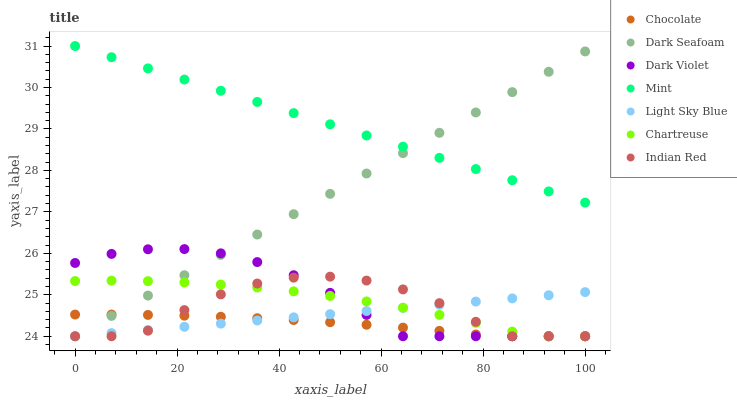Does Chocolate have the minimum area under the curve?
Answer yes or no. Yes. Does Mint have the maximum area under the curve?
Answer yes or no. Yes. Does Dark Violet have the minimum area under the curve?
Answer yes or no. No. Does Dark Violet have the maximum area under the curve?
Answer yes or no. No. Is Light Sky Blue the smoothest?
Answer yes or no. Yes. Is Indian Red the roughest?
Answer yes or no. Yes. Is Dark Violet the smoothest?
Answer yes or no. No. Is Dark Violet the roughest?
Answer yes or no. No. Does Chartreuse have the lowest value?
Answer yes or no. Yes. Does Mint have the lowest value?
Answer yes or no. No. Does Mint have the highest value?
Answer yes or no. Yes. Does Dark Violet have the highest value?
Answer yes or no. No. Is Light Sky Blue less than Mint?
Answer yes or no. Yes. Is Mint greater than Chartreuse?
Answer yes or no. Yes. Does Mint intersect Dark Seafoam?
Answer yes or no. Yes. Is Mint less than Dark Seafoam?
Answer yes or no. No. Is Mint greater than Dark Seafoam?
Answer yes or no. No. Does Light Sky Blue intersect Mint?
Answer yes or no. No. 